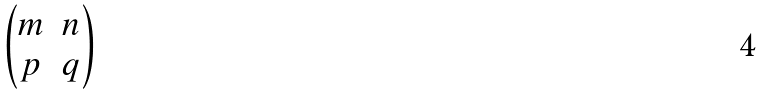Convert formula to latex. <formula><loc_0><loc_0><loc_500><loc_500>\begin{pmatrix} m & n \\ p & q \end{pmatrix}</formula> 